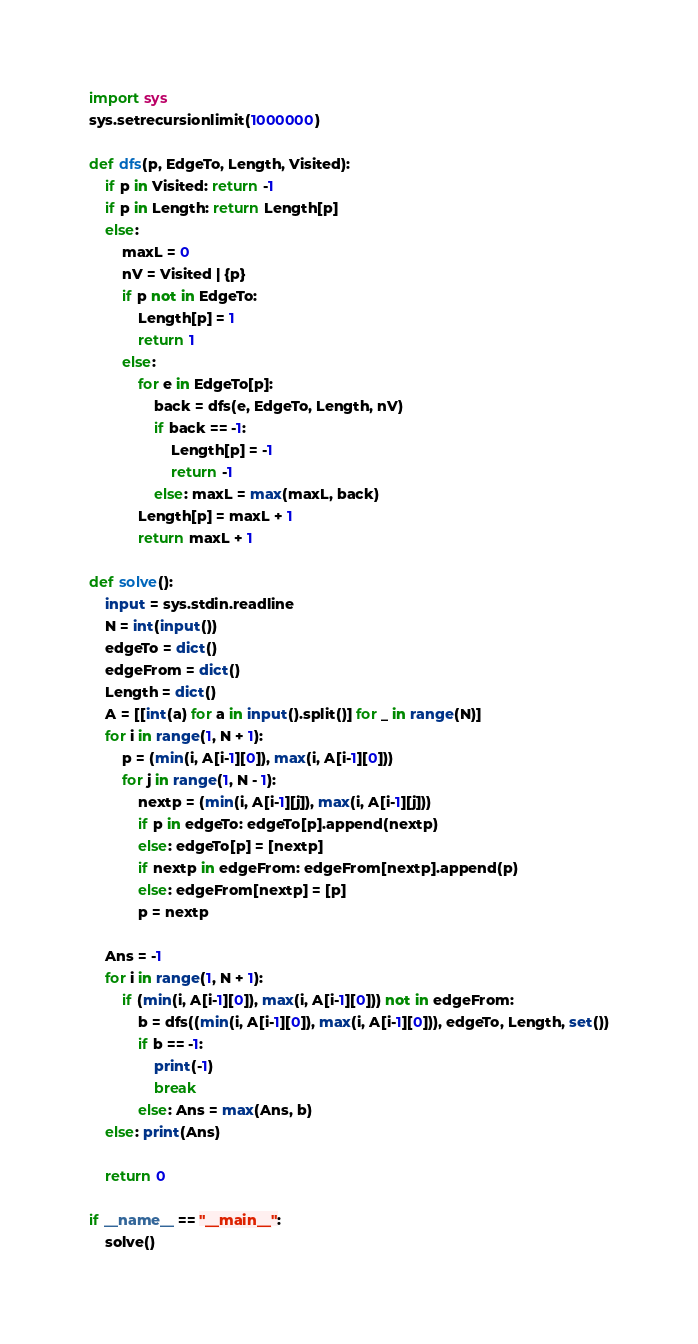Convert code to text. <code><loc_0><loc_0><loc_500><loc_500><_Python_>import sys
sys.setrecursionlimit(1000000)

def dfs(p, EdgeTo, Length, Visited):
    if p in Visited: return -1
    if p in Length: return Length[p]
    else:
        maxL = 0
        nV = Visited | {p}
        if p not in EdgeTo:
            Length[p] = 1
            return 1
        else:
            for e in EdgeTo[p]:
                back = dfs(e, EdgeTo, Length, nV)
                if back == -1:
                    Length[p] = -1
                    return -1
                else: maxL = max(maxL, back)
            Length[p] = maxL + 1
            return maxL + 1
        
def solve():
    input = sys.stdin.readline
    N = int(input())
    edgeTo = dict()
    edgeFrom = dict()
    Length = dict()
    A = [[int(a) for a in input().split()] for _ in range(N)]
    for i in range(1, N + 1):
        p = (min(i, A[i-1][0]), max(i, A[i-1][0]))
        for j in range(1, N - 1):
            nextp = (min(i, A[i-1][j]), max(i, A[i-1][j]))
            if p in edgeTo: edgeTo[p].append(nextp)
            else: edgeTo[p] = [nextp]
            if nextp in edgeFrom: edgeFrom[nextp].append(p)
            else: edgeFrom[nextp] = [p]
            p = nextp

    Ans = -1
    for i in range(1, N + 1):
        if (min(i, A[i-1][0]), max(i, A[i-1][0])) not in edgeFrom:
            b = dfs((min(i, A[i-1][0]), max(i, A[i-1][0])), edgeTo, Length, set())
            if b == -1:
                print(-1)
                break
            else: Ans = max(Ans, b)
    else: print(Ans)
            
    return 0

if __name__ == "__main__":
    solve()</code> 